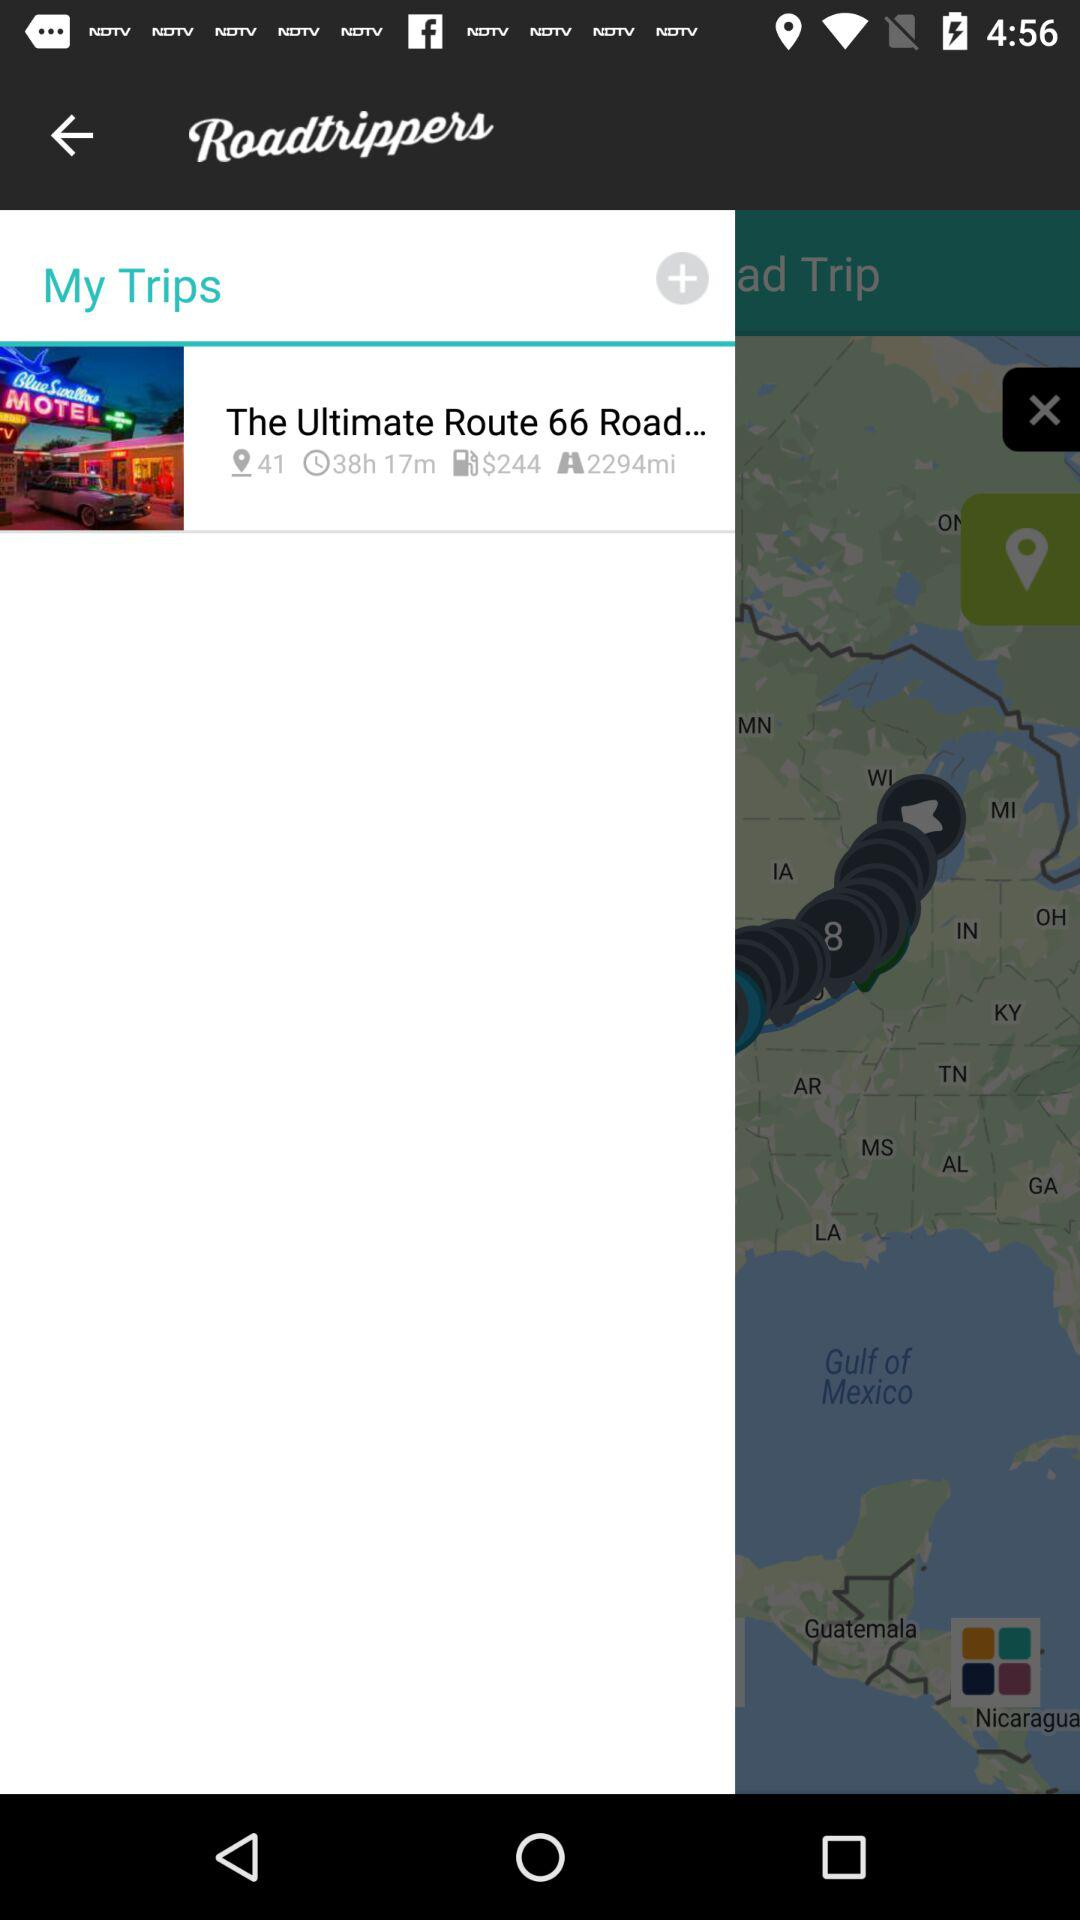What is the currency for the price of fuel? The currency is "Dollar". 